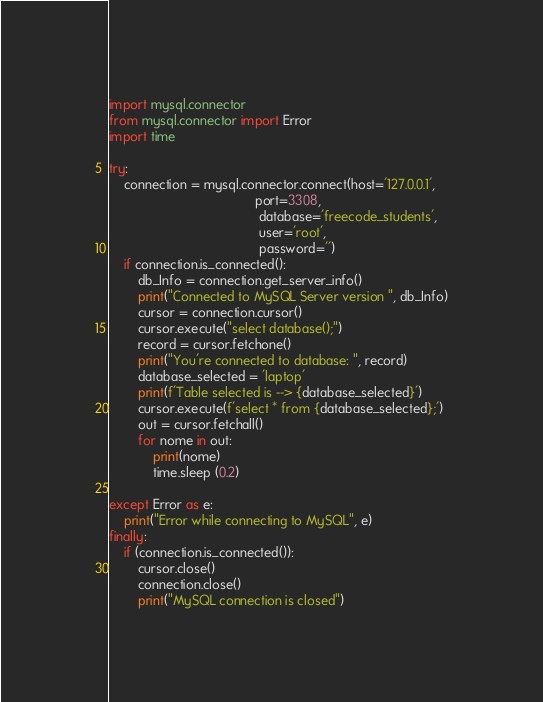<code> <loc_0><loc_0><loc_500><loc_500><_Python_>import mysql.connector
from mysql.connector import Error
import time

try:
    connection = mysql.connector.connect(host='127.0.0.1',
                                        port=3308,
                                         database='freecode_students',
                                         user='root',
                                         password='')
    if connection.is_connected():
        db_Info = connection.get_server_info()
        print("Connected to MySQL Server version ", db_Info)
        cursor = connection.cursor()
        cursor.execute("select database();")
        record = cursor.fetchone()
        print("You're connected to database: ", record)
        database_selected = 'laptop'
        print(f'Table selected is --> {database_selected}')
        cursor.execute(f'select * from {database_selected};')
        out = cursor.fetchall()
        for nome in out:
            print(nome)
            time.sleep (0.2)

except Error as e:
    print("Error while connecting to MySQL", e)
finally:
    if (connection.is_connected()):
        cursor.close()
        connection.close()
        print("MySQL connection is closed")</code> 